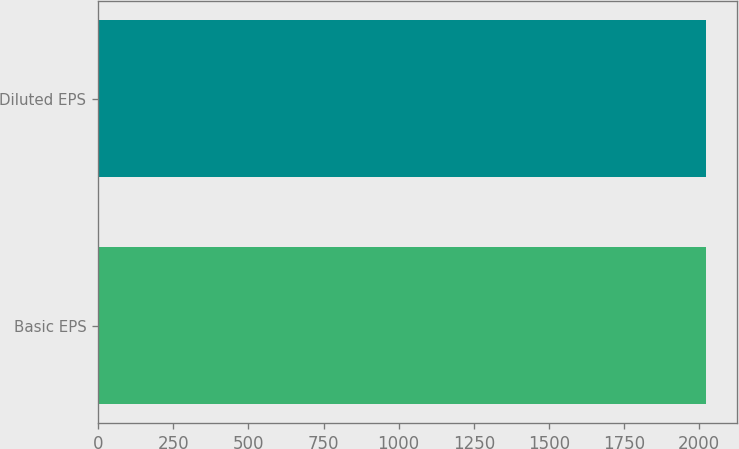Convert chart to OTSL. <chart><loc_0><loc_0><loc_500><loc_500><bar_chart><fcel>Basic EPS<fcel>Diluted EPS<nl><fcel>2024<fcel>2024.1<nl></chart> 